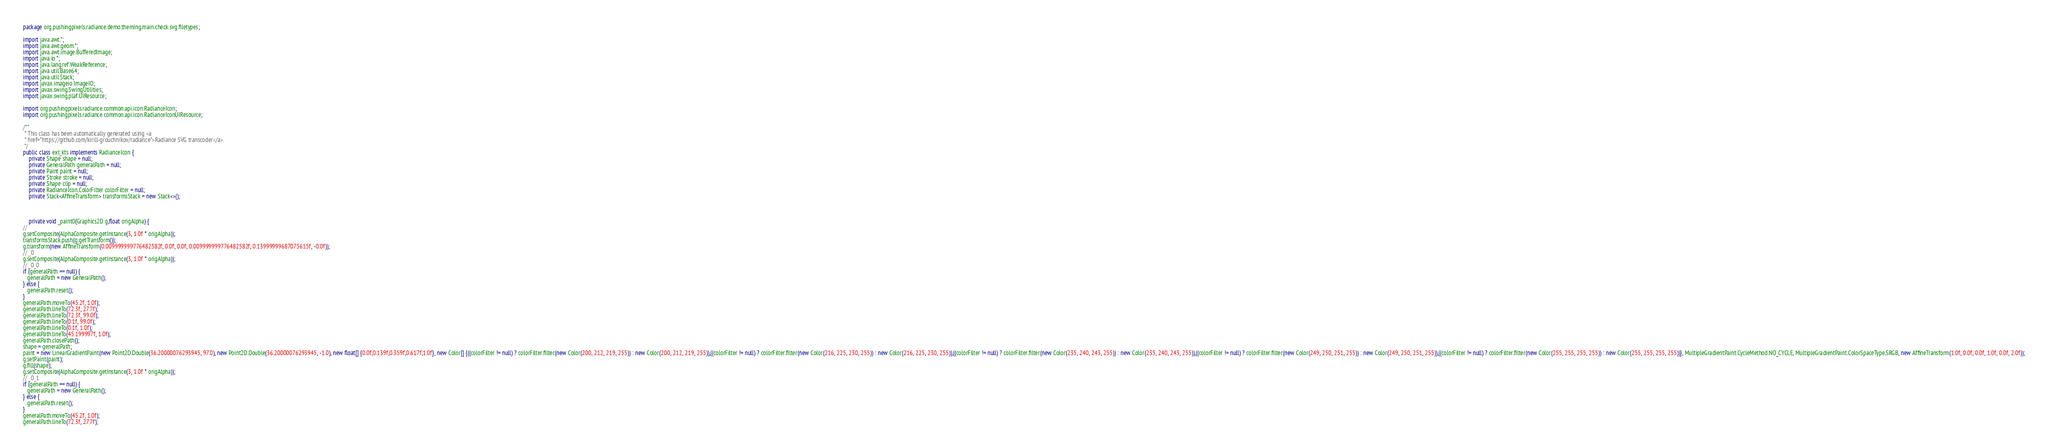<code> <loc_0><loc_0><loc_500><loc_500><_Java_>package org.pushingpixels.radiance.demo.theming.main.check.svg.filetypes;

import java.awt.*;
import java.awt.geom.*;
import java.awt.image.BufferedImage;
import java.io.*;
import java.lang.ref.WeakReference;
import java.util.Base64;
import java.util.Stack;
import javax.imageio.ImageIO;
import javax.swing.SwingUtilities;
import javax.swing.plaf.UIResource;

import org.pushingpixels.radiance.common.api.icon.RadianceIcon;
import org.pushingpixels.radiance.common.api.icon.RadianceIconUIResource;

/**
 * This class has been automatically generated using <a
 * href="https://github.com/kirill-grouchnikov/radiance">Radiance SVG transcoder</a>.
 */
public class ext_kts implements RadianceIcon {
    private Shape shape = null;
    private GeneralPath generalPath = null;
    private Paint paint = null;
    private Stroke stroke = null;
    private Shape clip = null;
    private RadianceIcon.ColorFilter colorFilter = null;
    private Stack<AffineTransform> transformsStack = new Stack<>();

    

	private void _paint0(Graphics2D g,float origAlpha) {
// 
g.setComposite(AlphaComposite.getInstance(3, 1.0f * origAlpha));
transformsStack.push(g.getTransform());
g.transform(new AffineTransform(0.009999999776482582f, 0.0f, 0.0f, 0.009999999776482582f, 0.13999999687075615f, -0.0f));
// _0
g.setComposite(AlphaComposite.getInstance(3, 1.0f * origAlpha));
// _0_0
if (generalPath == null) {
   generalPath = new GeneralPath();
} else {
   generalPath.reset();
}
generalPath.moveTo(45.2f, 1.0f);
generalPath.lineTo(72.3f, 27.7f);
generalPath.lineTo(72.3f, 99.0f);
generalPath.lineTo(0.1f, 99.0f);
generalPath.lineTo(0.1f, 1.0f);
generalPath.lineTo(45.199997f, 1.0f);
generalPath.closePath();
shape = generalPath;
paint = new LinearGradientPaint(new Point2D.Double(36.20000076293945, 97.0), new Point2D.Double(36.20000076293945, -1.0), new float[] {0.0f,0.139f,0.359f,0.617f,1.0f}, new Color[] {((colorFilter != null) ? colorFilter.filter(new Color(200, 212, 219, 255)) : new Color(200, 212, 219, 255)),((colorFilter != null) ? colorFilter.filter(new Color(216, 225, 230, 255)) : new Color(216, 225, 230, 255)),((colorFilter != null) ? colorFilter.filter(new Color(235, 240, 243, 255)) : new Color(235, 240, 243, 255)),((colorFilter != null) ? colorFilter.filter(new Color(249, 250, 251, 255)) : new Color(249, 250, 251, 255)),((colorFilter != null) ? colorFilter.filter(new Color(255, 255, 255, 255)) : new Color(255, 255, 255, 255))}, MultipleGradientPaint.CycleMethod.NO_CYCLE, MultipleGradientPaint.ColorSpaceType.SRGB, new AffineTransform(1.0f, 0.0f, 0.0f, 1.0f, 0.0f, 2.0f));
g.setPaint(paint);
g.fill(shape);
g.setComposite(AlphaComposite.getInstance(3, 1.0f * origAlpha));
// _0_1
if (generalPath == null) {
   generalPath = new GeneralPath();
} else {
   generalPath.reset();
}
generalPath.moveTo(45.2f, 1.0f);
generalPath.lineTo(72.3f, 27.7f);</code> 